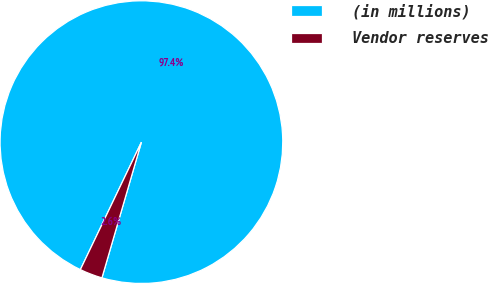<chart> <loc_0><loc_0><loc_500><loc_500><pie_chart><fcel>(in millions)<fcel>Vendor reserves<nl><fcel>97.4%<fcel>2.6%<nl></chart> 